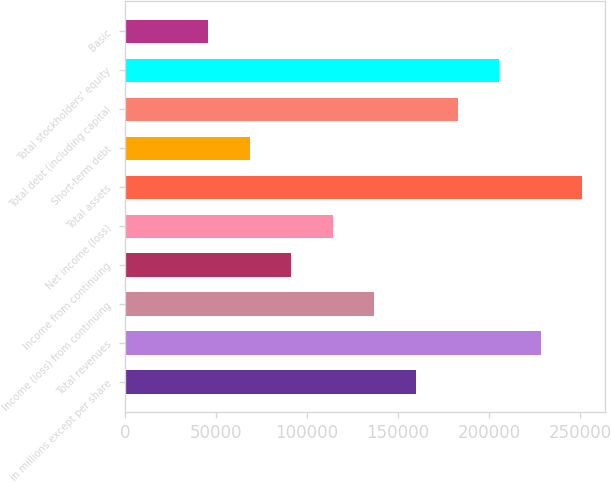Convert chart. <chart><loc_0><loc_0><loc_500><loc_500><bar_chart><fcel>in millions except per share<fcel>Total revenues<fcel>Income (loss) from continuing<fcel>Income from continuing<fcel>Net income (loss)<fcel>Total assets<fcel>Short-term debt<fcel>Total debt (including capital<fcel>Total stockholders' equity<fcel>Basic<nl><fcel>159844<fcel>228348<fcel>137009<fcel>91339.7<fcel>114174<fcel>251183<fcel>68504.9<fcel>182679<fcel>205513<fcel>45670.2<nl></chart> 